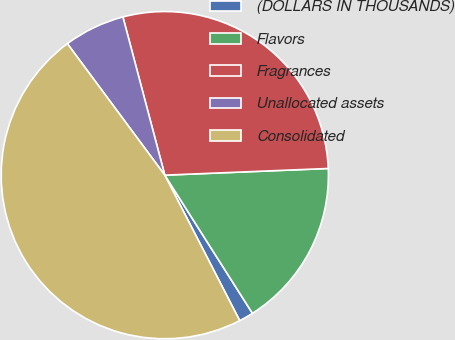Convert chart. <chart><loc_0><loc_0><loc_500><loc_500><pie_chart><fcel>(DOLLARS IN THOUSANDS)<fcel>Flavors<fcel>Fragrances<fcel>Unallocated assets<fcel>Consolidated<nl><fcel>1.43%<fcel>16.65%<fcel>28.47%<fcel>6.03%<fcel>47.42%<nl></chart> 